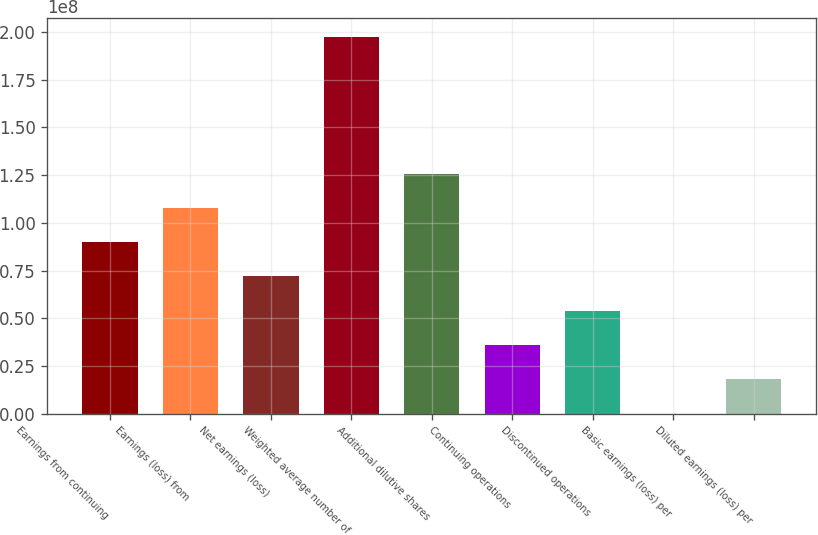<chart> <loc_0><loc_0><loc_500><loc_500><bar_chart><fcel>Earnings from continuing<fcel>Earnings (loss) from<fcel>Net earnings (loss)<fcel>Weighted average number of<fcel>Additional dilutive shares<fcel>Continuing operations<fcel>Discontinued operations<fcel>Basic earnings (loss) per<fcel>Diluted earnings (loss) per<nl><fcel>8.99139e+07<fcel>1.07897e+08<fcel>7.19311e+07<fcel>1.9735e+08<fcel>1.25879e+08<fcel>3.59656e+07<fcel>5.39483e+07<fcel>0.06<fcel>1.79828e+07<nl></chart> 